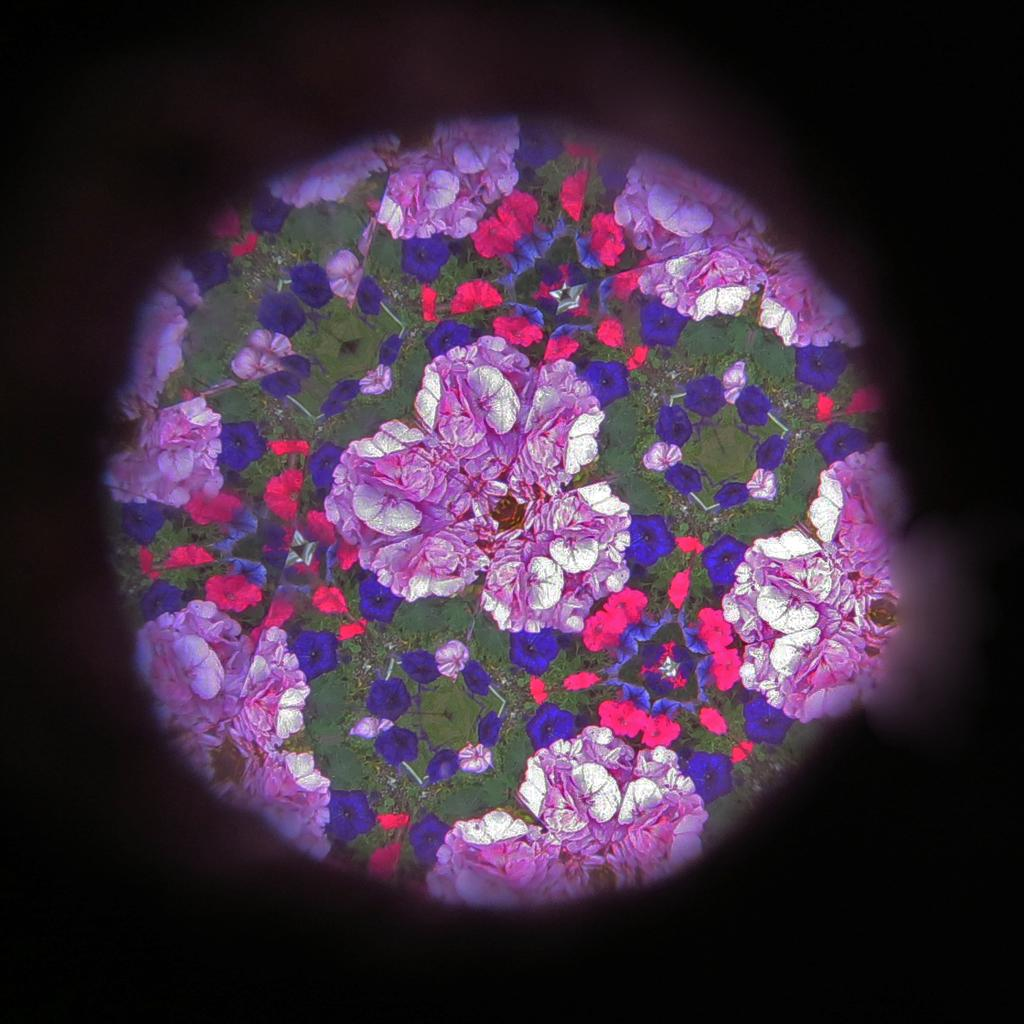What is the main subject of the image? The main subject of the image is colorful flowers. Where are the flowers located in the image? The flowers are in the middle of the image. What can be observed about the background of the image? The background of the image is dark. What type of butter is being used to answer questions in the image? There is no butter or answering of questions present in the image; it features colorful flowers with a dark background. 